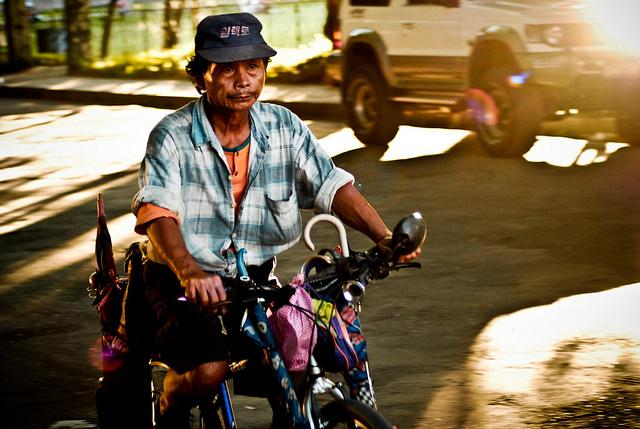Why do they have so many umbrellas? Please explain your reasoning. selling them. The umbrellas are for sale. 